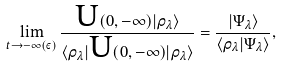Convert formula to latex. <formula><loc_0><loc_0><loc_500><loc_500>\lim _ { t \rightarrow - \infty ( \varepsilon ) } \frac { \text {U} ( 0 , - \infty ) | \rho _ { \lambda } \rangle } { \langle \rho _ { \lambda } | \text {U} ( 0 , - \infty ) | \rho _ { \lambda } \rangle } = \frac { | \Psi _ { \lambda } \rangle } { \langle \rho _ { \lambda } | \Psi _ { \lambda } \rangle } ,</formula> 